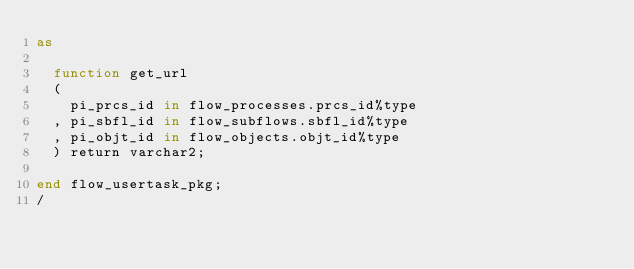<code> <loc_0><loc_0><loc_500><loc_500><_SQL_>as

  function get_url
  (
    pi_prcs_id in flow_processes.prcs_id%type
  , pi_sbfl_id in flow_subflows.sbfl_id%type
  , pi_objt_id in flow_objects.objt_id%type
  ) return varchar2;

end flow_usertask_pkg;
/
</code> 